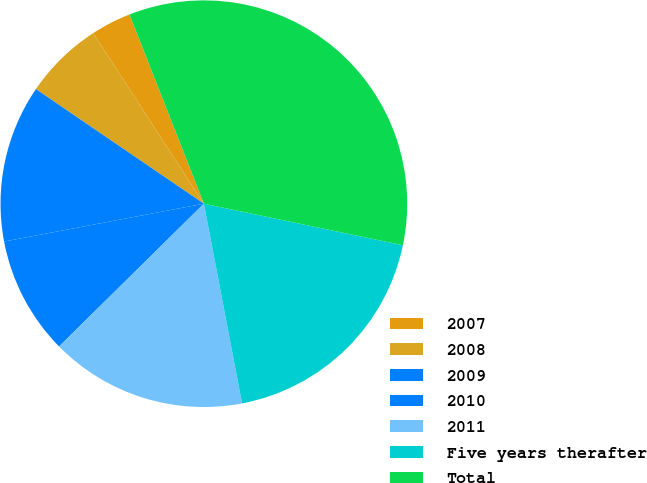<chart> <loc_0><loc_0><loc_500><loc_500><pie_chart><fcel>2007<fcel>2008<fcel>2009<fcel>2010<fcel>2011<fcel>Five years therafter<fcel>Total<nl><fcel>3.2%<fcel>6.31%<fcel>12.51%<fcel>9.41%<fcel>15.62%<fcel>18.72%<fcel>34.24%<nl></chart> 